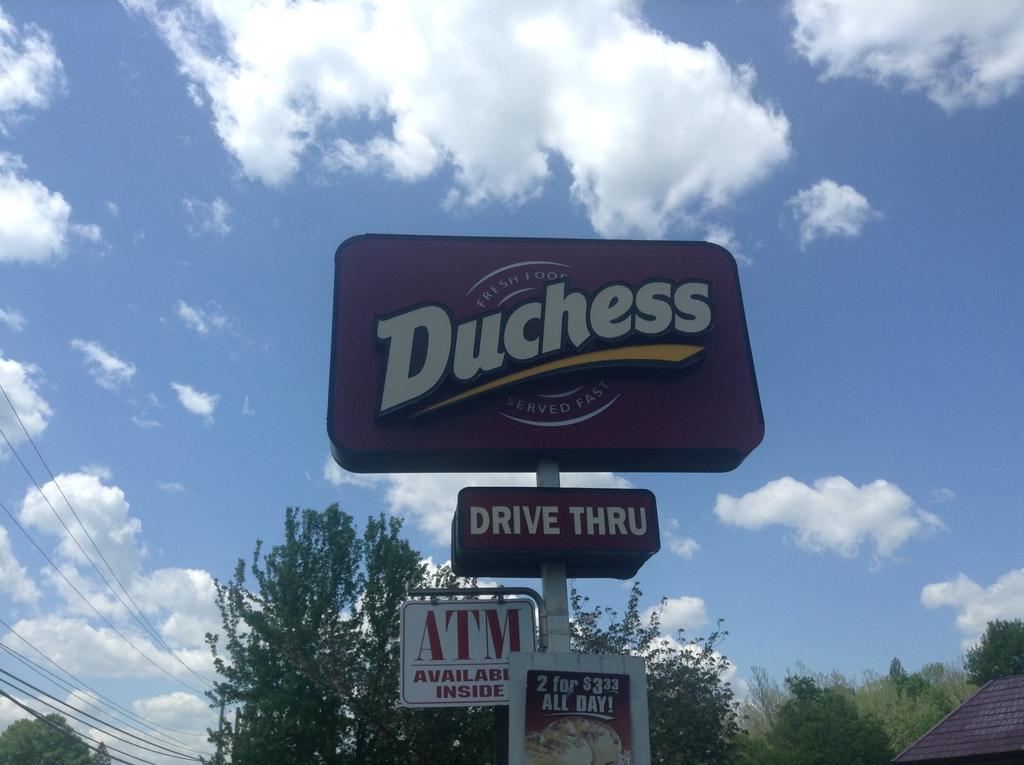What restaurant has a drive thru?
Your answer should be compact. Duchess. What is the name of the restaurant?
Offer a terse response. Duchess. 